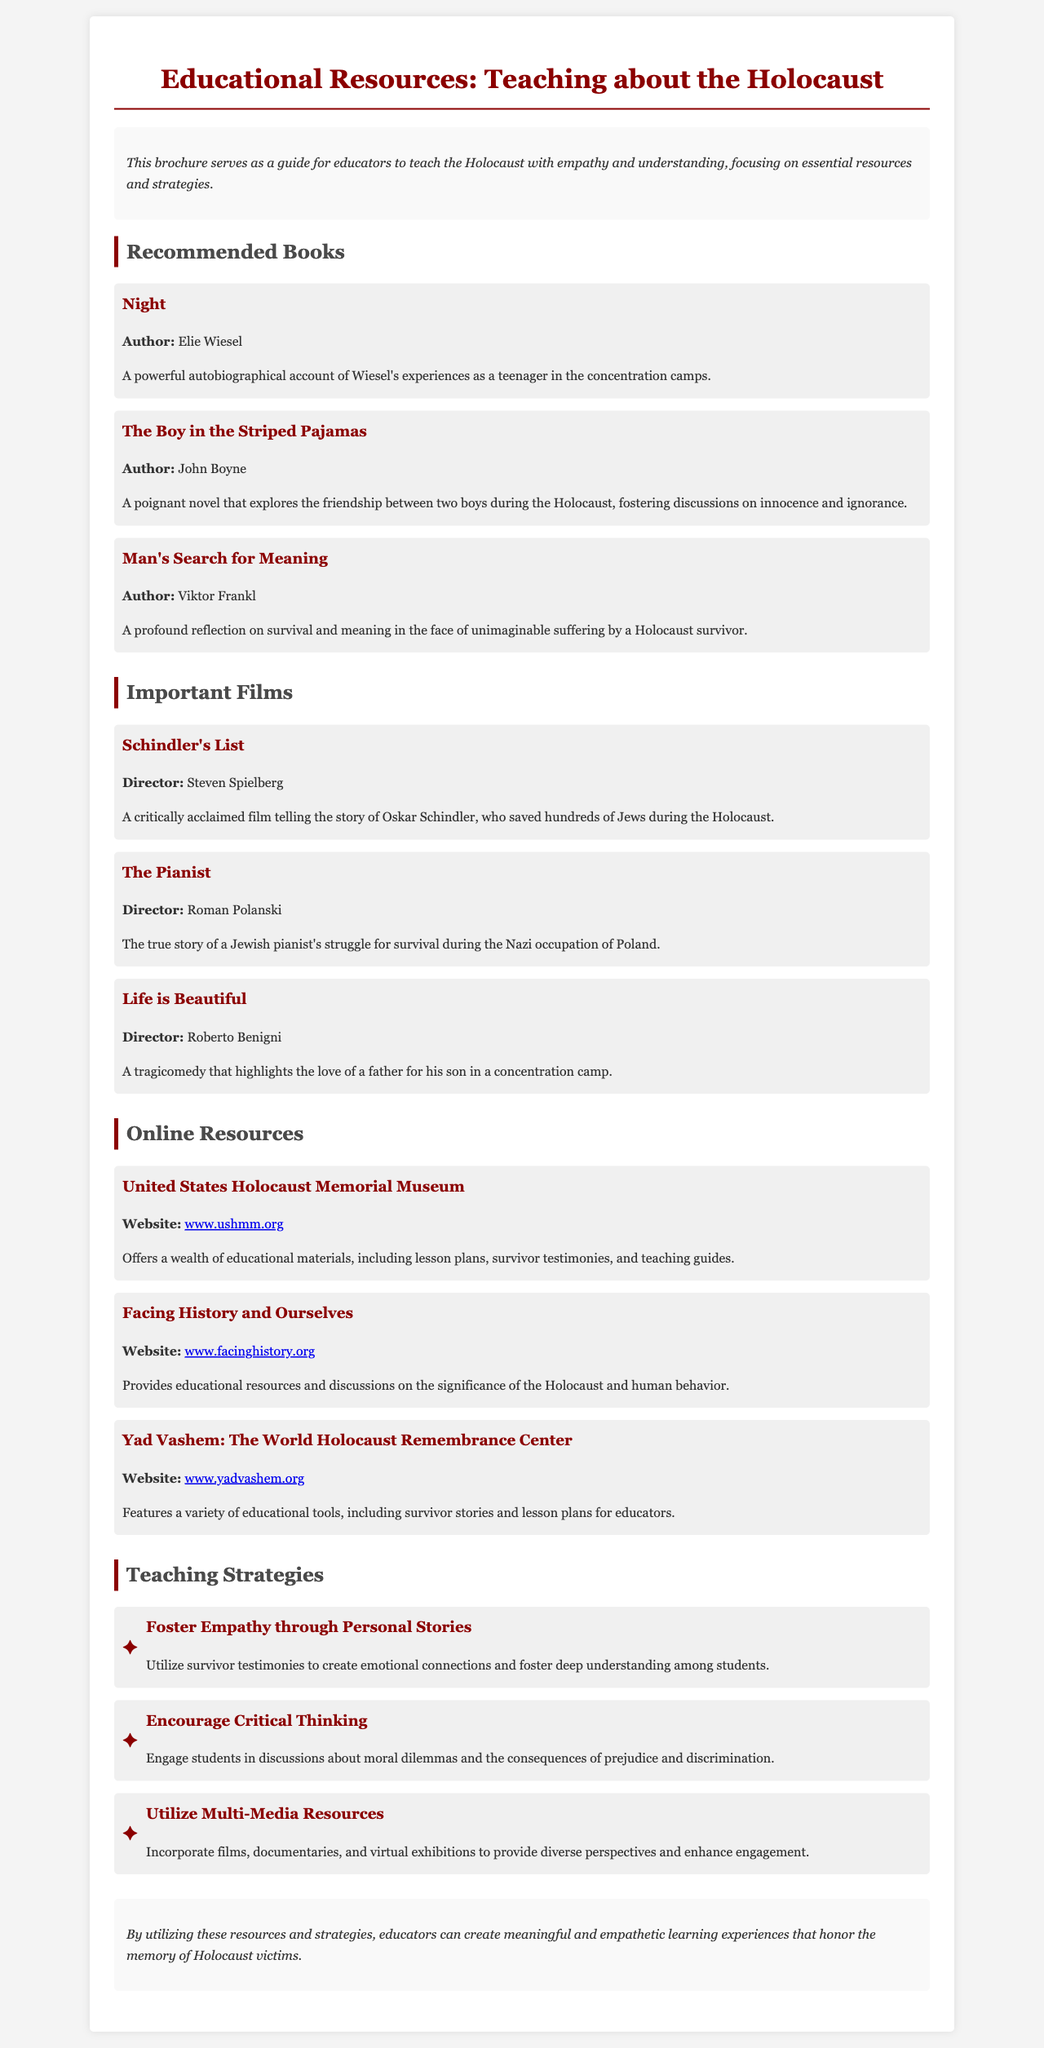what is the title of the brochure? The title is prominently displayed at the top of the document, highlighting the focus of the resources provided.
Answer: Educational Resources: Teaching about the Holocaust who is the author of "Night"? The authorship of this influential book is mentioned in the recommended books section.
Answer: Elie Wiesel what type of strategies are included in the brochure? The brochure outlines various approaches aimed at enhancing understanding and empathy related to the Holocaust.
Answer: Teaching Strategies how many films are listed in the "Important Films" section? The number of films can be counted in the corresponding section of the document.
Answer: Three what is the website for the United States Holocaust Memorial Museum? The brochure provides a specific URL for this resource under the online resources section.
Answer: www.ushmm.org which book is described as a poignant novel about friendship during the Holocaust? The description in the recommended books section mentions themes of friendship within this particular book.
Answer: The Boy in the Striped Pajamas which film tells the story of a Jewish pianist's struggle during the Holocaust? The document states that this film depicts the life of a Jewish pianist during a significant historical event.
Answer: The Pianist what is one way to foster empathy suggested in the brochure? The strategies section offers ideas on engaging students to develop empathy using personal stories.
Answer: Foster Empathy through Personal Stories what is the color of the headline in the brochure? The color is specified in the styling section and serves as a visual highlight for important text.
Answer: Dark red 